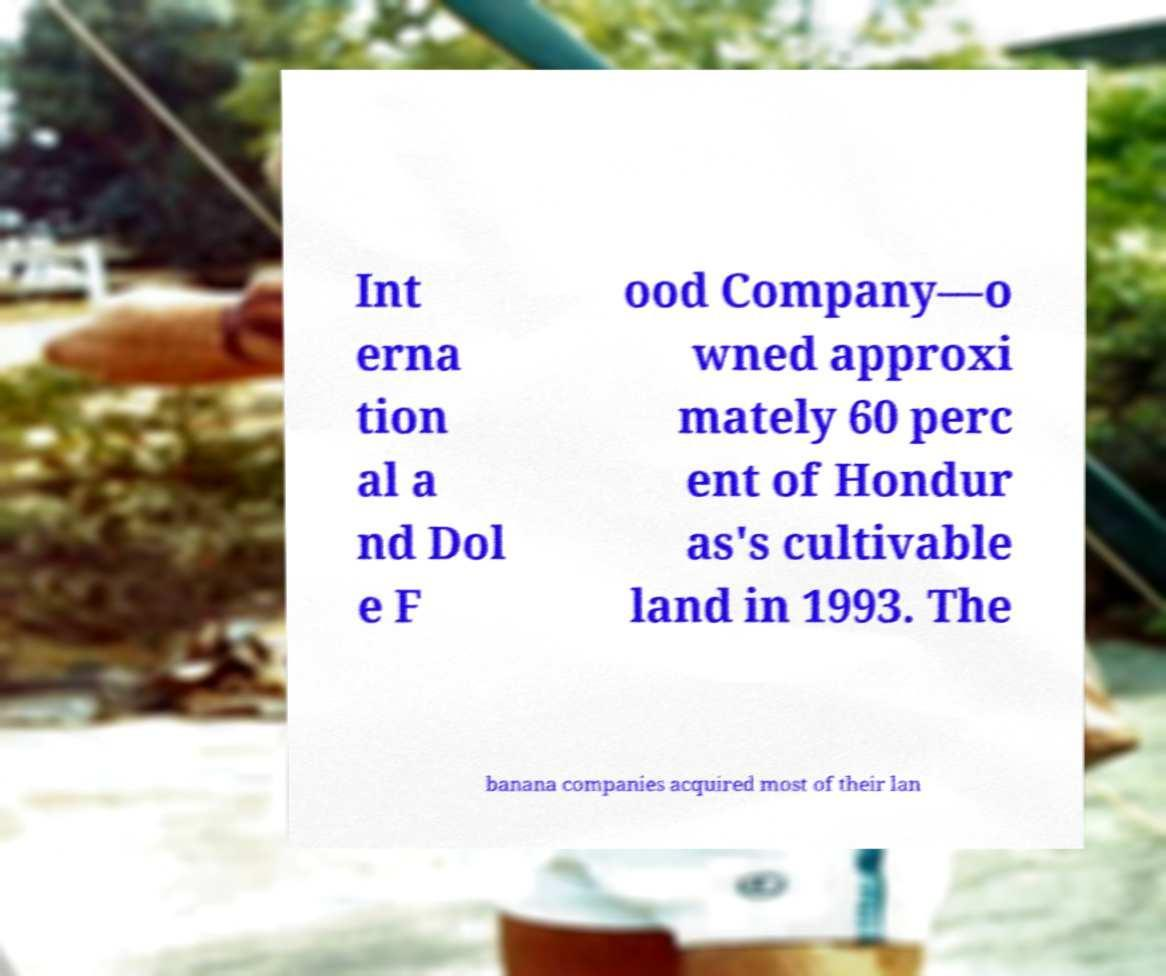Could you assist in decoding the text presented in this image and type it out clearly? Int erna tion al a nd Dol e F ood Company—o wned approxi mately 60 perc ent of Hondur as's cultivable land in 1993. The banana companies acquired most of their lan 